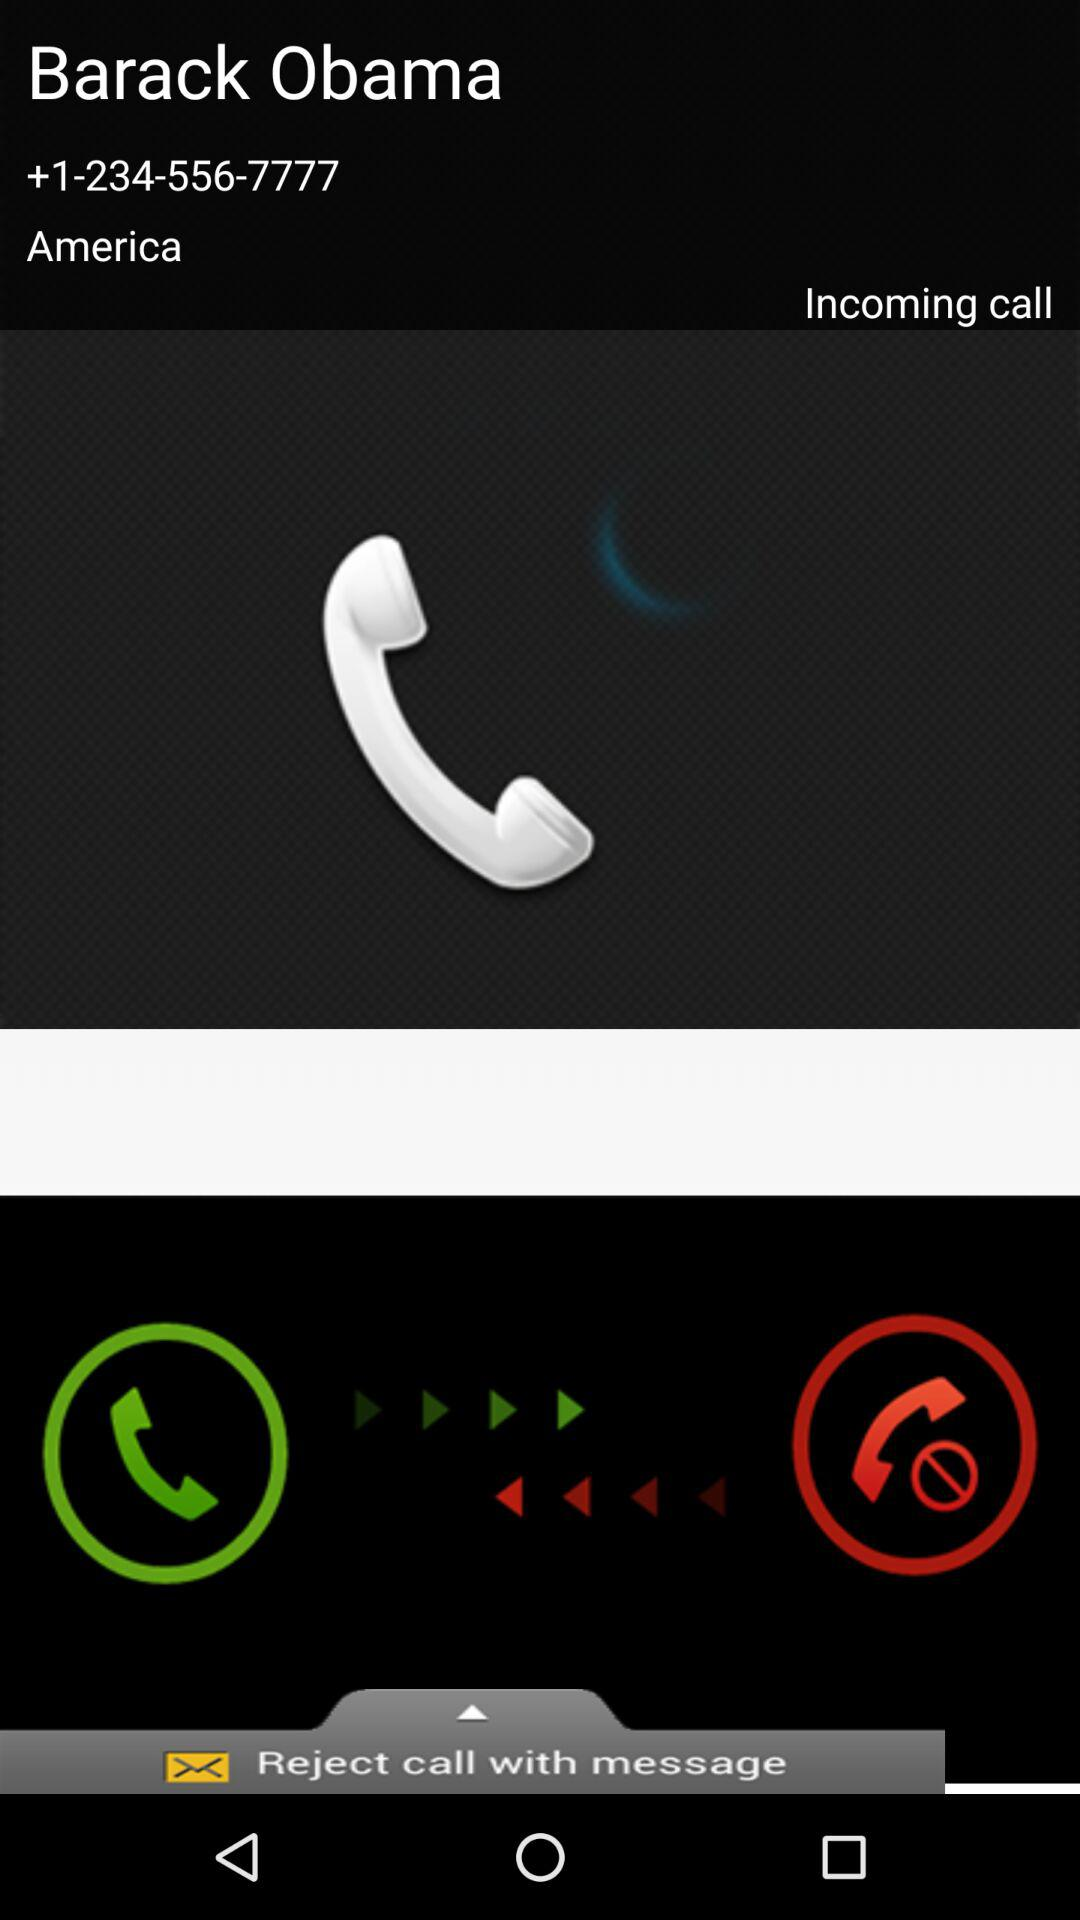What is the name of the country shown on the screen? The name of the country shown on the screen is America. 